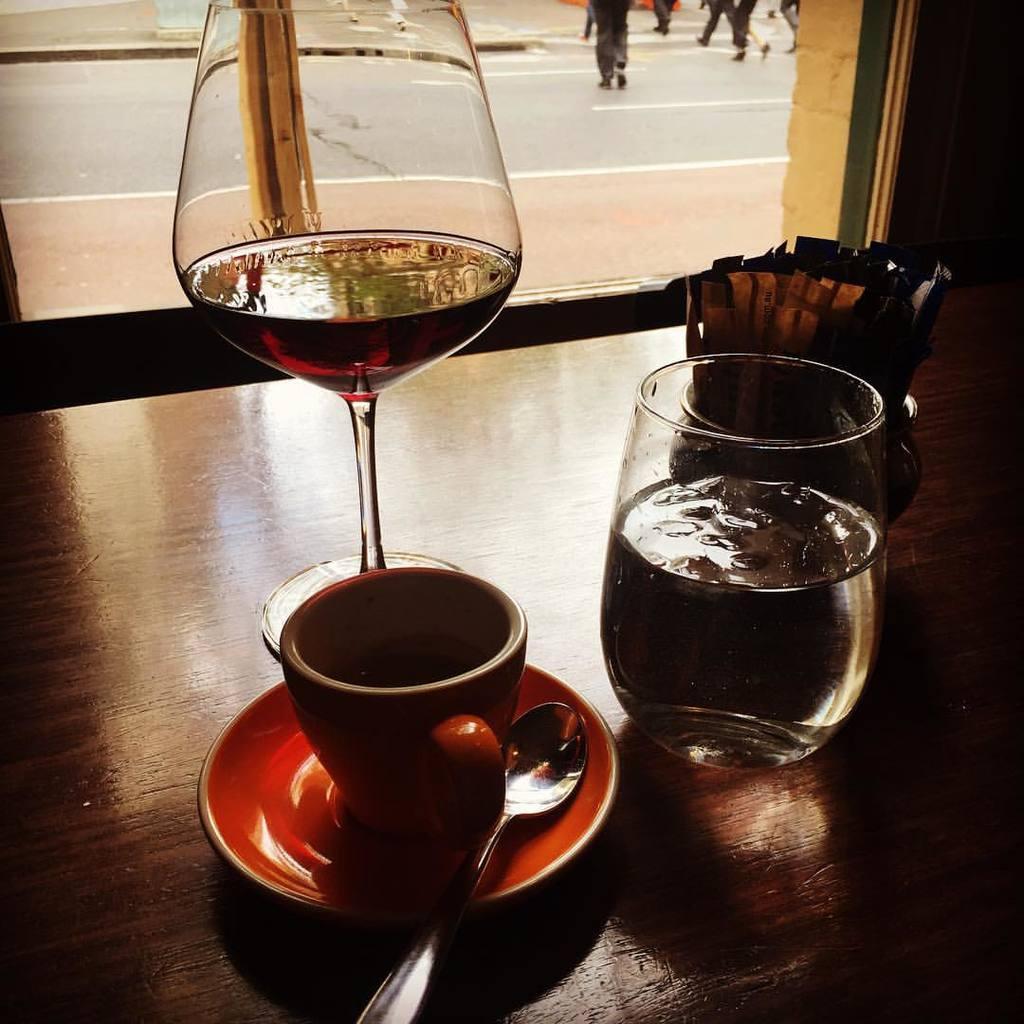How would you summarize this image in a sentence or two? In this picture, we can see the table with jar, cup, glass and some liquids in it, we can see some object on the table, we can see glass, from the glass we can see a few people, and the road. 